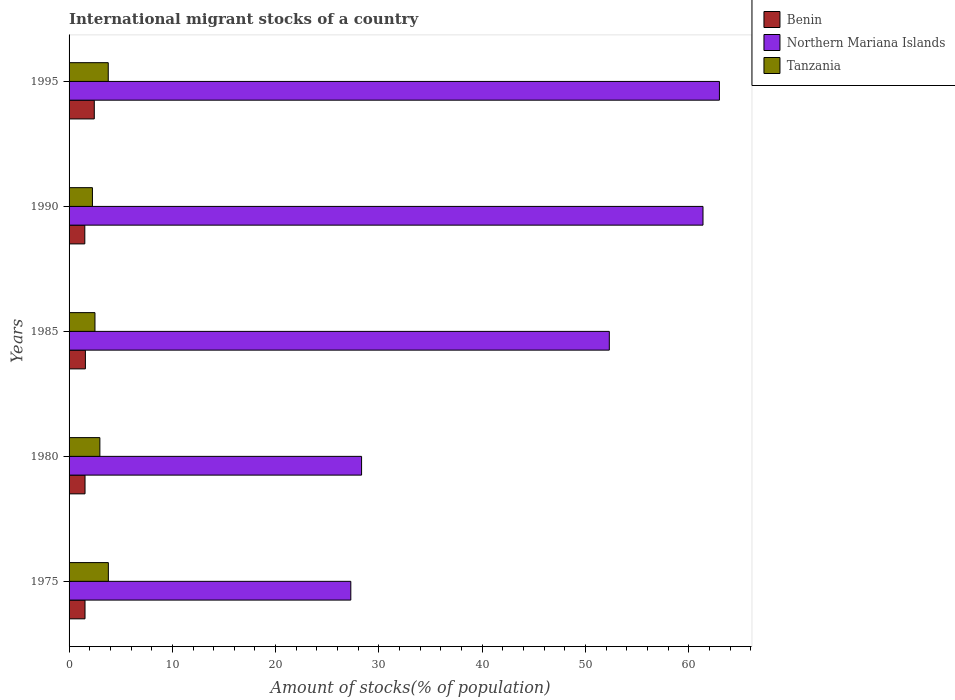Are the number of bars per tick equal to the number of legend labels?
Make the answer very short. Yes. Are the number of bars on each tick of the Y-axis equal?
Offer a terse response. Yes. How many bars are there on the 5th tick from the bottom?
Offer a very short reply. 3. What is the label of the 5th group of bars from the top?
Make the answer very short. 1975. What is the amount of stocks in in Benin in 1995?
Make the answer very short. 2.44. Across all years, what is the maximum amount of stocks in in Tanzania?
Make the answer very short. 3.8. Across all years, what is the minimum amount of stocks in in Benin?
Offer a very short reply. 1.52. What is the total amount of stocks in in Northern Mariana Islands in the graph?
Your answer should be very brief. 232.25. What is the difference between the amount of stocks in in Tanzania in 1980 and that in 1985?
Give a very brief answer. 0.47. What is the difference between the amount of stocks in in Northern Mariana Islands in 1985 and the amount of stocks in in Tanzania in 1995?
Provide a succinct answer. 48.51. What is the average amount of stocks in in Benin per year?
Provide a succinct answer. 1.73. In the year 1995, what is the difference between the amount of stocks in in Tanzania and amount of stocks in in Benin?
Your answer should be compact. 1.35. What is the ratio of the amount of stocks in in Benin in 1990 to that in 1995?
Keep it short and to the point. 0.62. Is the difference between the amount of stocks in in Tanzania in 1975 and 1995 greater than the difference between the amount of stocks in in Benin in 1975 and 1995?
Your answer should be very brief. Yes. What is the difference between the highest and the second highest amount of stocks in in Benin?
Make the answer very short. 0.86. What is the difference between the highest and the lowest amount of stocks in in Benin?
Make the answer very short. 0.92. Is the sum of the amount of stocks in in Benin in 1985 and 1995 greater than the maximum amount of stocks in in Tanzania across all years?
Offer a terse response. Yes. What does the 2nd bar from the top in 1990 represents?
Your response must be concise. Northern Mariana Islands. What does the 3rd bar from the bottom in 1975 represents?
Provide a succinct answer. Tanzania. How many bars are there?
Provide a short and direct response. 15. Are all the bars in the graph horizontal?
Offer a terse response. Yes. How many years are there in the graph?
Provide a succinct answer. 5. Does the graph contain any zero values?
Give a very brief answer. No. Does the graph contain grids?
Keep it short and to the point. No. How many legend labels are there?
Your response must be concise. 3. What is the title of the graph?
Provide a short and direct response. International migrant stocks of a country. Does "Czech Republic" appear as one of the legend labels in the graph?
Offer a very short reply. No. What is the label or title of the X-axis?
Your response must be concise. Amount of stocks(% of population). What is the Amount of stocks(% of population) in Benin in 1975?
Give a very brief answer. 1.54. What is the Amount of stocks(% of population) of Northern Mariana Islands in 1975?
Your answer should be compact. 27.28. What is the Amount of stocks(% of population) of Tanzania in 1975?
Provide a succinct answer. 3.8. What is the Amount of stocks(% of population) in Benin in 1980?
Your response must be concise. 1.54. What is the Amount of stocks(% of population) in Northern Mariana Islands in 1980?
Provide a succinct answer. 28.32. What is the Amount of stocks(% of population) in Tanzania in 1980?
Ensure brevity in your answer.  2.98. What is the Amount of stocks(% of population) of Benin in 1985?
Give a very brief answer. 1.58. What is the Amount of stocks(% of population) in Northern Mariana Islands in 1985?
Offer a very short reply. 52.31. What is the Amount of stocks(% of population) of Tanzania in 1985?
Ensure brevity in your answer.  2.51. What is the Amount of stocks(% of population) in Benin in 1990?
Ensure brevity in your answer.  1.52. What is the Amount of stocks(% of population) of Northern Mariana Islands in 1990?
Provide a succinct answer. 61.38. What is the Amount of stocks(% of population) in Tanzania in 1990?
Your answer should be compact. 2.26. What is the Amount of stocks(% of population) of Benin in 1995?
Offer a very short reply. 2.44. What is the Amount of stocks(% of population) in Northern Mariana Islands in 1995?
Offer a terse response. 62.97. What is the Amount of stocks(% of population) of Tanzania in 1995?
Your answer should be very brief. 3.79. Across all years, what is the maximum Amount of stocks(% of population) in Benin?
Keep it short and to the point. 2.44. Across all years, what is the maximum Amount of stocks(% of population) of Northern Mariana Islands?
Keep it short and to the point. 62.97. Across all years, what is the maximum Amount of stocks(% of population) of Tanzania?
Your response must be concise. 3.8. Across all years, what is the minimum Amount of stocks(% of population) in Benin?
Your answer should be very brief. 1.52. Across all years, what is the minimum Amount of stocks(% of population) of Northern Mariana Islands?
Your answer should be very brief. 27.28. Across all years, what is the minimum Amount of stocks(% of population) of Tanzania?
Make the answer very short. 2.26. What is the total Amount of stocks(% of population) in Benin in the graph?
Provide a succinct answer. 8.63. What is the total Amount of stocks(% of population) of Northern Mariana Islands in the graph?
Provide a succinct answer. 232.25. What is the total Amount of stocks(% of population) in Tanzania in the graph?
Make the answer very short. 15.35. What is the difference between the Amount of stocks(% of population) in Benin in 1975 and that in 1980?
Keep it short and to the point. -0. What is the difference between the Amount of stocks(% of population) of Northern Mariana Islands in 1975 and that in 1980?
Keep it short and to the point. -1.04. What is the difference between the Amount of stocks(% of population) in Tanzania in 1975 and that in 1980?
Give a very brief answer. 0.82. What is the difference between the Amount of stocks(% of population) in Benin in 1975 and that in 1985?
Offer a terse response. -0.04. What is the difference between the Amount of stocks(% of population) in Northern Mariana Islands in 1975 and that in 1985?
Make the answer very short. -25.03. What is the difference between the Amount of stocks(% of population) of Tanzania in 1975 and that in 1985?
Give a very brief answer. 1.3. What is the difference between the Amount of stocks(% of population) in Benin in 1975 and that in 1990?
Your answer should be compact. 0.02. What is the difference between the Amount of stocks(% of population) in Northern Mariana Islands in 1975 and that in 1990?
Your response must be concise. -34.1. What is the difference between the Amount of stocks(% of population) of Tanzania in 1975 and that in 1990?
Your answer should be very brief. 1.54. What is the difference between the Amount of stocks(% of population) of Benin in 1975 and that in 1995?
Keep it short and to the point. -0.9. What is the difference between the Amount of stocks(% of population) of Northern Mariana Islands in 1975 and that in 1995?
Ensure brevity in your answer.  -35.69. What is the difference between the Amount of stocks(% of population) in Tanzania in 1975 and that in 1995?
Make the answer very short. 0.01. What is the difference between the Amount of stocks(% of population) of Benin in 1980 and that in 1985?
Keep it short and to the point. -0.03. What is the difference between the Amount of stocks(% of population) of Northern Mariana Islands in 1980 and that in 1985?
Keep it short and to the point. -23.99. What is the difference between the Amount of stocks(% of population) in Tanzania in 1980 and that in 1985?
Give a very brief answer. 0.47. What is the difference between the Amount of stocks(% of population) of Benin in 1980 and that in 1990?
Your answer should be very brief. 0.02. What is the difference between the Amount of stocks(% of population) of Northern Mariana Islands in 1980 and that in 1990?
Make the answer very short. -33.06. What is the difference between the Amount of stocks(% of population) in Tanzania in 1980 and that in 1990?
Your response must be concise. 0.72. What is the difference between the Amount of stocks(% of population) in Benin in 1980 and that in 1995?
Provide a short and direct response. -0.9. What is the difference between the Amount of stocks(% of population) of Northern Mariana Islands in 1980 and that in 1995?
Make the answer very short. -34.65. What is the difference between the Amount of stocks(% of population) in Tanzania in 1980 and that in 1995?
Your answer should be very brief. -0.81. What is the difference between the Amount of stocks(% of population) of Benin in 1985 and that in 1990?
Ensure brevity in your answer.  0.06. What is the difference between the Amount of stocks(% of population) in Northern Mariana Islands in 1985 and that in 1990?
Keep it short and to the point. -9.07. What is the difference between the Amount of stocks(% of population) of Tanzania in 1985 and that in 1990?
Keep it short and to the point. 0.24. What is the difference between the Amount of stocks(% of population) of Benin in 1985 and that in 1995?
Provide a short and direct response. -0.86. What is the difference between the Amount of stocks(% of population) in Northern Mariana Islands in 1985 and that in 1995?
Provide a succinct answer. -10.66. What is the difference between the Amount of stocks(% of population) of Tanzania in 1985 and that in 1995?
Give a very brief answer. -1.29. What is the difference between the Amount of stocks(% of population) of Benin in 1990 and that in 1995?
Your response must be concise. -0.92. What is the difference between the Amount of stocks(% of population) in Northern Mariana Islands in 1990 and that in 1995?
Your response must be concise. -1.59. What is the difference between the Amount of stocks(% of population) in Tanzania in 1990 and that in 1995?
Give a very brief answer. -1.53. What is the difference between the Amount of stocks(% of population) of Benin in 1975 and the Amount of stocks(% of population) of Northern Mariana Islands in 1980?
Keep it short and to the point. -26.78. What is the difference between the Amount of stocks(% of population) of Benin in 1975 and the Amount of stocks(% of population) of Tanzania in 1980?
Provide a succinct answer. -1.44. What is the difference between the Amount of stocks(% of population) of Northern Mariana Islands in 1975 and the Amount of stocks(% of population) of Tanzania in 1980?
Give a very brief answer. 24.3. What is the difference between the Amount of stocks(% of population) in Benin in 1975 and the Amount of stocks(% of population) in Northern Mariana Islands in 1985?
Offer a very short reply. -50.76. What is the difference between the Amount of stocks(% of population) of Benin in 1975 and the Amount of stocks(% of population) of Tanzania in 1985?
Ensure brevity in your answer.  -0.96. What is the difference between the Amount of stocks(% of population) of Northern Mariana Islands in 1975 and the Amount of stocks(% of population) of Tanzania in 1985?
Give a very brief answer. 24.77. What is the difference between the Amount of stocks(% of population) in Benin in 1975 and the Amount of stocks(% of population) in Northern Mariana Islands in 1990?
Offer a very short reply. -59.83. What is the difference between the Amount of stocks(% of population) in Benin in 1975 and the Amount of stocks(% of population) in Tanzania in 1990?
Your answer should be very brief. -0.72. What is the difference between the Amount of stocks(% of population) in Northern Mariana Islands in 1975 and the Amount of stocks(% of population) in Tanzania in 1990?
Offer a very short reply. 25.02. What is the difference between the Amount of stocks(% of population) in Benin in 1975 and the Amount of stocks(% of population) in Northern Mariana Islands in 1995?
Keep it short and to the point. -61.42. What is the difference between the Amount of stocks(% of population) in Benin in 1975 and the Amount of stocks(% of population) in Tanzania in 1995?
Your answer should be compact. -2.25. What is the difference between the Amount of stocks(% of population) of Northern Mariana Islands in 1975 and the Amount of stocks(% of population) of Tanzania in 1995?
Provide a succinct answer. 23.48. What is the difference between the Amount of stocks(% of population) of Benin in 1980 and the Amount of stocks(% of population) of Northern Mariana Islands in 1985?
Offer a very short reply. -50.76. What is the difference between the Amount of stocks(% of population) of Benin in 1980 and the Amount of stocks(% of population) of Tanzania in 1985?
Provide a succinct answer. -0.96. What is the difference between the Amount of stocks(% of population) in Northern Mariana Islands in 1980 and the Amount of stocks(% of population) in Tanzania in 1985?
Provide a succinct answer. 25.81. What is the difference between the Amount of stocks(% of population) in Benin in 1980 and the Amount of stocks(% of population) in Northern Mariana Islands in 1990?
Your answer should be compact. -59.83. What is the difference between the Amount of stocks(% of population) of Benin in 1980 and the Amount of stocks(% of population) of Tanzania in 1990?
Ensure brevity in your answer.  -0.72. What is the difference between the Amount of stocks(% of population) of Northern Mariana Islands in 1980 and the Amount of stocks(% of population) of Tanzania in 1990?
Ensure brevity in your answer.  26.06. What is the difference between the Amount of stocks(% of population) of Benin in 1980 and the Amount of stocks(% of population) of Northern Mariana Islands in 1995?
Offer a very short reply. -61.42. What is the difference between the Amount of stocks(% of population) of Benin in 1980 and the Amount of stocks(% of population) of Tanzania in 1995?
Your response must be concise. -2.25. What is the difference between the Amount of stocks(% of population) in Northern Mariana Islands in 1980 and the Amount of stocks(% of population) in Tanzania in 1995?
Make the answer very short. 24.53. What is the difference between the Amount of stocks(% of population) in Benin in 1985 and the Amount of stocks(% of population) in Northern Mariana Islands in 1990?
Make the answer very short. -59.8. What is the difference between the Amount of stocks(% of population) in Benin in 1985 and the Amount of stocks(% of population) in Tanzania in 1990?
Your answer should be very brief. -0.68. What is the difference between the Amount of stocks(% of population) of Northern Mariana Islands in 1985 and the Amount of stocks(% of population) of Tanzania in 1990?
Provide a short and direct response. 50.04. What is the difference between the Amount of stocks(% of population) in Benin in 1985 and the Amount of stocks(% of population) in Northern Mariana Islands in 1995?
Your response must be concise. -61.39. What is the difference between the Amount of stocks(% of population) in Benin in 1985 and the Amount of stocks(% of population) in Tanzania in 1995?
Your answer should be very brief. -2.21. What is the difference between the Amount of stocks(% of population) in Northern Mariana Islands in 1985 and the Amount of stocks(% of population) in Tanzania in 1995?
Make the answer very short. 48.51. What is the difference between the Amount of stocks(% of population) of Benin in 1990 and the Amount of stocks(% of population) of Northern Mariana Islands in 1995?
Provide a succinct answer. -61.44. What is the difference between the Amount of stocks(% of population) in Benin in 1990 and the Amount of stocks(% of population) in Tanzania in 1995?
Offer a very short reply. -2.27. What is the difference between the Amount of stocks(% of population) in Northern Mariana Islands in 1990 and the Amount of stocks(% of population) in Tanzania in 1995?
Make the answer very short. 57.58. What is the average Amount of stocks(% of population) in Benin per year?
Provide a succinct answer. 1.73. What is the average Amount of stocks(% of population) in Northern Mariana Islands per year?
Offer a terse response. 46.45. What is the average Amount of stocks(% of population) in Tanzania per year?
Provide a short and direct response. 3.07. In the year 1975, what is the difference between the Amount of stocks(% of population) of Benin and Amount of stocks(% of population) of Northern Mariana Islands?
Keep it short and to the point. -25.73. In the year 1975, what is the difference between the Amount of stocks(% of population) of Benin and Amount of stocks(% of population) of Tanzania?
Your answer should be compact. -2.26. In the year 1975, what is the difference between the Amount of stocks(% of population) of Northern Mariana Islands and Amount of stocks(% of population) of Tanzania?
Make the answer very short. 23.47. In the year 1980, what is the difference between the Amount of stocks(% of population) of Benin and Amount of stocks(% of population) of Northern Mariana Islands?
Provide a succinct answer. -26.78. In the year 1980, what is the difference between the Amount of stocks(% of population) in Benin and Amount of stocks(% of population) in Tanzania?
Offer a terse response. -1.44. In the year 1980, what is the difference between the Amount of stocks(% of population) in Northern Mariana Islands and Amount of stocks(% of population) in Tanzania?
Offer a very short reply. 25.34. In the year 1985, what is the difference between the Amount of stocks(% of population) in Benin and Amount of stocks(% of population) in Northern Mariana Islands?
Keep it short and to the point. -50.73. In the year 1985, what is the difference between the Amount of stocks(% of population) of Benin and Amount of stocks(% of population) of Tanzania?
Offer a very short reply. -0.93. In the year 1985, what is the difference between the Amount of stocks(% of population) in Northern Mariana Islands and Amount of stocks(% of population) in Tanzania?
Provide a succinct answer. 49.8. In the year 1990, what is the difference between the Amount of stocks(% of population) of Benin and Amount of stocks(% of population) of Northern Mariana Islands?
Your response must be concise. -59.85. In the year 1990, what is the difference between the Amount of stocks(% of population) of Benin and Amount of stocks(% of population) of Tanzania?
Ensure brevity in your answer.  -0.74. In the year 1990, what is the difference between the Amount of stocks(% of population) of Northern Mariana Islands and Amount of stocks(% of population) of Tanzania?
Give a very brief answer. 59.11. In the year 1995, what is the difference between the Amount of stocks(% of population) in Benin and Amount of stocks(% of population) in Northern Mariana Islands?
Your answer should be very brief. -60.52. In the year 1995, what is the difference between the Amount of stocks(% of population) of Benin and Amount of stocks(% of population) of Tanzania?
Provide a short and direct response. -1.35. In the year 1995, what is the difference between the Amount of stocks(% of population) in Northern Mariana Islands and Amount of stocks(% of population) in Tanzania?
Your answer should be very brief. 59.17. What is the ratio of the Amount of stocks(% of population) of Benin in 1975 to that in 1980?
Ensure brevity in your answer.  1. What is the ratio of the Amount of stocks(% of population) of Northern Mariana Islands in 1975 to that in 1980?
Give a very brief answer. 0.96. What is the ratio of the Amount of stocks(% of population) of Tanzania in 1975 to that in 1980?
Provide a succinct answer. 1.28. What is the ratio of the Amount of stocks(% of population) of Benin in 1975 to that in 1985?
Offer a terse response. 0.98. What is the ratio of the Amount of stocks(% of population) in Northern Mariana Islands in 1975 to that in 1985?
Offer a terse response. 0.52. What is the ratio of the Amount of stocks(% of population) of Tanzania in 1975 to that in 1985?
Ensure brevity in your answer.  1.52. What is the ratio of the Amount of stocks(% of population) of Benin in 1975 to that in 1990?
Keep it short and to the point. 1.01. What is the ratio of the Amount of stocks(% of population) of Northern Mariana Islands in 1975 to that in 1990?
Your response must be concise. 0.44. What is the ratio of the Amount of stocks(% of population) of Tanzania in 1975 to that in 1990?
Your response must be concise. 1.68. What is the ratio of the Amount of stocks(% of population) in Benin in 1975 to that in 1995?
Give a very brief answer. 0.63. What is the ratio of the Amount of stocks(% of population) in Northern Mariana Islands in 1975 to that in 1995?
Offer a terse response. 0.43. What is the ratio of the Amount of stocks(% of population) in Benin in 1980 to that in 1985?
Your answer should be compact. 0.98. What is the ratio of the Amount of stocks(% of population) of Northern Mariana Islands in 1980 to that in 1985?
Provide a short and direct response. 0.54. What is the ratio of the Amount of stocks(% of population) in Tanzania in 1980 to that in 1985?
Make the answer very short. 1.19. What is the ratio of the Amount of stocks(% of population) in Benin in 1980 to that in 1990?
Provide a short and direct response. 1.01. What is the ratio of the Amount of stocks(% of population) in Northern Mariana Islands in 1980 to that in 1990?
Your answer should be very brief. 0.46. What is the ratio of the Amount of stocks(% of population) in Tanzania in 1980 to that in 1990?
Your response must be concise. 1.32. What is the ratio of the Amount of stocks(% of population) in Benin in 1980 to that in 1995?
Your answer should be very brief. 0.63. What is the ratio of the Amount of stocks(% of population) in Northern Mariana Islands in 1980 to that in 1995?
Provide a succinct answer. 0.45. What is the ratio of the Amount of stocks(% of population) in Tanzania in 1980 to that in 1995?
Keep it short and to the point. 0.79. What is the ratio of the Amount of stocks(% of population) of Benin in 1985 to that in 1990?
Your answer should be compact. 1.04. What is the ratio of the Amount of stocks(% of population) of Northern Mariana Islands in 1985 to that in 1990?
Offer a terse response. 0.85. What is the ratio of the Amount of stocks(% of population) of Tanzania in 1985 to that in 1990?
Keep it short and to the point. 1.11. What is the ratio of the Amount of stocks(% of population) of Benin in 1985 to that in 1995?
Your answer should be compact. 0.65. What is the ratio of the Amount of stocks(% of population) in Northern Mariana Islands in 1985 to that in 1995?
Your answer should be compact. 0.83. What is the ratio of the Amount of stocks(% of population) in Tanzania in 1985 to that in 1995?
Provide a succinct answer. 0.66. What is the ratio of the Amount of stocks(% of population) in Benin in 1990 to that in 1995?
Provide a succinct answer. 0.62. What is the ratio of the Amount of stocks(% of population) in Northern Mariana Islands in 1990 to that in 1995?
Your answer should be compact. 0.97. What is the ratio of the Amount of stocks(% of population) in Tanzania in 1990 to that in 1995?
Your answer should be compact. 0.6. What is the difference between the highest and the second highest Amount of stocks(% of population) in Benin?
Your answer should be compact. 0.86. What is the difference between the highest and the second highest Amount of stocks(% of population) in Northern Mariana Islands?
Offer a terse response. 1.59. What is the difference between the highest and the second highest Amount of stocks(% of population) in Tanzania?
Your answer should be compact. 0.01. What is the difference between the highest and the lowest Amount of stocks(% of population) in Benin?
Provide a succinct answer. 0.92. What is the difference between the highest and the lowest Amount of stocks(% of population) of Northern Mariana Islands?
Offer a terse response. 35.69. What is the difference between the highest and the lowest Amount of stocks(% of population) in Tanzania?
Offer a terse response. 1.54. 